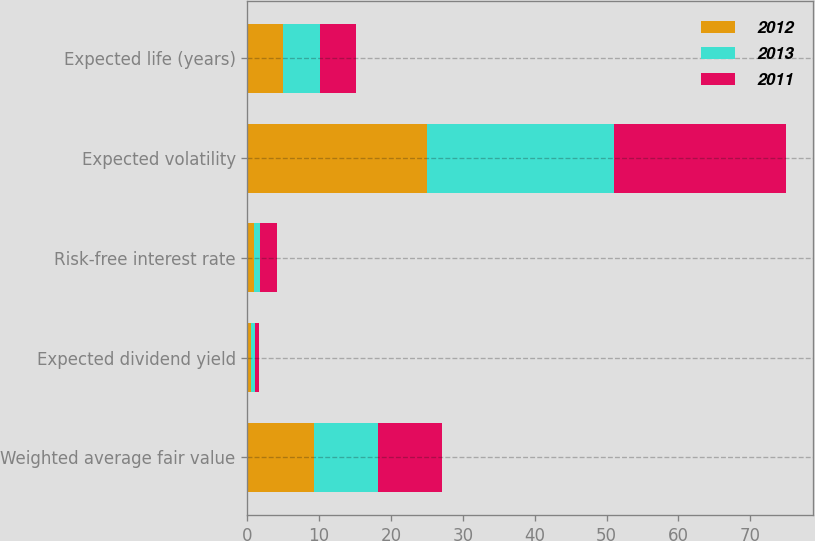Convert chart. <chart><loc_0><loc_0><loc_500><loc_500><stacked_bar_chart><ecel><fcel>Weighted average fair value<fcel>Expected dividend yield<fcel>Risk-free interest rate<fcel>Expected volatility<fcel>Expected life (years)<nl><fcel>2012<fcel>9.3<fcel>0.53<fcel>0.87<fcel>25<fcel>4.98<nl><fcel>2013<fcel>8.91<fcel>0.57<fcel>0.93<fcel>26<fcel>5.1<nl><fcel>2011<fcel>8.86<fcel>0.55<fcel>2.35<fcel>24<fcel>5.07<nl></chart> 